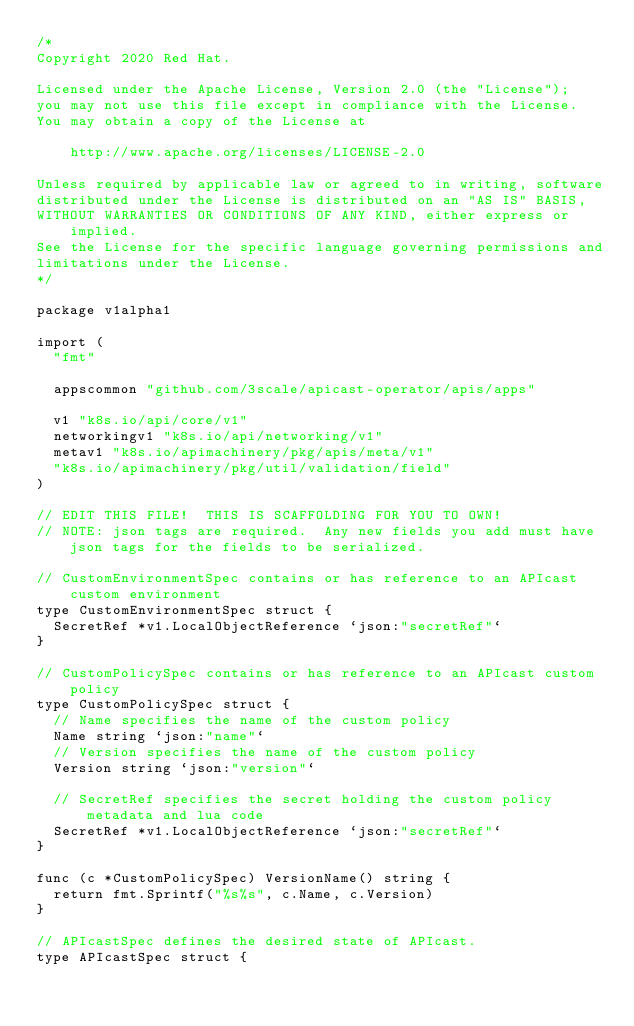<code> <loc_0><loc_0><loc_500><loc_500><_Go_>/*
Copyright 2020 Red Hat.

Licensed under the Apache License, Version 2.0 (the "License");
you may not use this file except in compliance with the License.
You may obtain a copy of the License at

    http://www.apache.org/licenses/LICENSE-2.0

Unless required by applicable law or agreed to in writing, software
distributed under the License is distributed on an "AS IS" BASIS,
WITHOUT WARRANTIES OR CONDITIONS OF ANY KIND, either express or implied.
See the License for the specific language governing permissions and
limitations under the License.
*/

package v1alpha1

import (
	"fmt"

	appscommon "github.com/3scale/apicast-operator/apis/apps"

	v1 "k8s.io/api/core/v1"
	networkingv1 "k8s.io/api/networking/v1"
	metav1 "k8s.io/apimachinery/pkg/apis/meta/v1"
	"k8s.io/apimachinery/pkg/util/validation/field"
)

// EDIT THIS FILE!  THIS IS SCAFFOLDING FOR YOU TO OWN!
// NOTE: json tags are required.  Any new fields you add must have json tags for the fields to be serialized.

// CustomEnvironmentSpec contains or has reference to an APIcast custom environment
type CustomEnvironmentSpec struct {
	SecretRef *v1.LocalObjectReference `json:"secretRef"`
}

// CustomPolicySpec contains or has reference to an APIcast custom policy
type CustomPolicySpec struct {
	// Name specifies the name of the custom policy
	Name string `json:"name"`
	// Version specifies the name of the custom policy
	Version string `json:"version"`

	// SecretRef specifies the secret holding the custom policy metadata and lua code
	SecretRef *v1.LocalObjectReference `json:"secretRef"`
}

func (c *CustomPolicySpec) VersionName() string {
	return fmt.Sprintf("%s%s", c.Name, c.Version)
}

// APIcastSpec defines the desired state of APIcast.
type APIcastSpec struct {</code> 